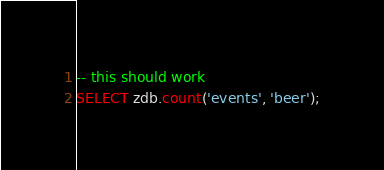<code> <loc_0><loc_0><loc_500><loc_500><_SQL_>-- this should work
SELECT zdb.count('events', 'beer');</code> 